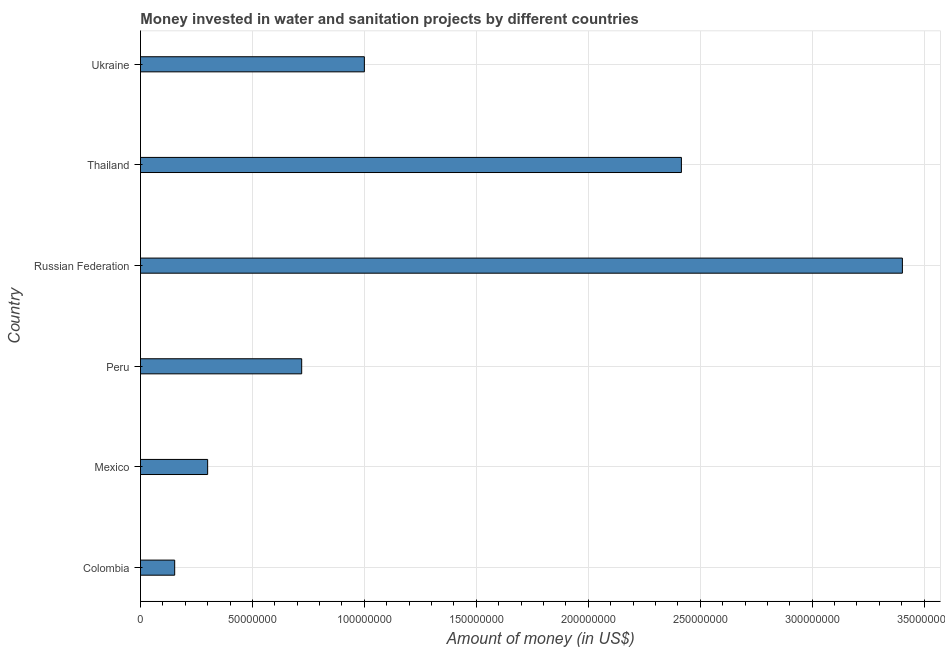Does the graph contain any zero values?
Your answer should be very brief. No. What is the title of the graph?
Your answer should be compact. Money invested in water and sanitation projects by different countries. What is the label or title of the X-axis?
Your answer should be compact. Amount of money (in US$). What is the label or title of the Y-axis?
Your answer should be compact. Country. What is the investment in Mexico?
Provide a short and direct response. 3.00e+07. Across all countries, what is the maximum investment?
Offer a very short reply. 3.40e+08. Across all countries, what is the minimum investment?
Your answer should be compact. 1.53e+07. In which country was the investment maximum?
Offer a terse response. Russian Federation. In which country was the investment minimum?
Keep it short and to the point. Colombia. What is the sum of the investment?
Ensure brevity in your answer.  7.99e+08. What is the difference between the investment in Colombia and Russian Federation?
Keep it short and to the point. -3.25e+08. What is the average investment per country?
Ensure brevity in your answer.  1.33e+08. What is the median investment?
Provide a succinct answer. 8.60e+07. In how many countries, is the investment greater than 80000000 US$?
Give a very brief answer. 3. What is the ratio of the investment in Peru to that in Ukraine?
Your response must be concise. 0.72. What is the difference between the highest and the second highest investment?
Give a very brief answer. 9.87e+07. Is the sum of the investment in Thailand and Ukraine greater than the maximum investment across all countries?
Keep it short and to the point. Yes. What is the difference between the highest and the lowest investment?
Provide a short and direct response. 3.25e+08. In how many countries, is the investment greater than the average investment taken over all countries?
Make the answer very short. 2. How many countries are there in the graph?
Your answer should be very brief. 6. Are the values on the major ticks of X-axis written in scientific E-notation?
Make the answer very short. No. What is the Amount of money (in US$) in Colombia?
Offer a very short reply. 1.53e+07. What is the Amount of money (in US$) of Mexico?
Offer a very short reply. 3.00e+07. What is the Amount of money (in US$) in Peru?
Provide a succinct answer. 7.20e+07. What is the Amount of money (in US$) of Russian Federation?
Offer a terse response. 3.40e+08. What is the Amount of money (in US$) in Thailand?
Ensure brevity in your answer.  2.42e+08. What is the difference between the Amount of money (in US$) in Colombia and Mexico?
Ensure brevity in your answer.  -1.47e+07. What is the difference between the Amount of money (in US$) in Colombia and Peru?
Keep it short and to the point. -5.67e+07. What is the difference between the Amount of money (in US$) in Colombia and Russian Federation?
Keep it short and to the point. -3.25e+08. What is the difference between the Amount of money (in US$) in Colombia and Thailand?
Offer a very short reply. -2.26e+08. What is the difference between the Amount of money (in US$) in Colombia and Ukraine?
Provide a short and direct response. -8.47e+07. What is the difference between the Amount of money (in US$) in Mexico and Peru?
Ensure brevity in your answer.  -4.20e+07. What is the difference between the Amount of money (in US$) in Mexico and Russian Federation?
Keep it short and to the point. -3.10e+08. What is the difference between the Amount of money (in US$) in Mexico and Thailand?
Your answer should be compact. -2.12e+08. What is the difference between the Amount of money (in US$) in Mexico and Ukraine?
Offer a terse response. -7.00e+07. What is the difference between the Amount of money (in US$) in Peru and Russian Federation?
Ensure brevity in your answer.  -2.68e+08. What is the difference between the Amount of money (in US$) in Peru and Thailand?
Provide a succinct answer. -1.70e+08. What is the difference between the Amount of money (in US$) in Peru and Ukraine?
Your answer should be compact. -2.80e+07. What is the difference between the Amount of money (in US$) in Russian Federation and Thailand?
Ensure brevity in your answer.  9.87e+07. What is the difference between the Amount of money (in US$) in Russian Federation and Ukraine?
Ensure brevity in your answer.  2.40e+08. What is the difference between the Amount of money (in US$) in Thailand and Ukraine?
Offer a very short reply. 1.42e+08. What is the ratio of the Amount of money (in US$) in Colombia to that in Mexico?
Ensure brevity in your answer.  0.51. What is the ratio of the Amount of money (in US$) in Colombia to that in Peru?
Your response must be concise. 0.21. What is the ratio of the Amount of money (in US$) in Colombia to that in Russian Federation?
Offer a very short reply. 0.04. What is the ratio of the Amount of money (in US$) in Colombia to that in Thailand?
Offer a very short reply. 0.06. What is the ratio of the Amount of money (in US$) in Colombia to that in Ukraine?
Provide a succinct answer. 0.15. What is the ratio of the Amount of money (in US$) in Mexico to that in Peru?
Keep it short and to the point. 0.42. What is the ratio of the Amount of money (in US$) in Mexico to that in Russian Federation?
Provide a succinct answer. 0.09. What is the ratio of the Amount of money (in US$) in Mexico to that in Thailand?
Keep it short and to the point. 0.12. What is the ratio of the Amount of money (in US$) in Peru to that in Russian Federation?
Make the answer very short. 0.21. What is the ratio of the Amount of money (in US$) in Peru to that in Thailand?
Offer a very short reply. 0.3. What is the ratio of the Amount of money (in US$) in Peru to that in Ukraine?
Your response must be concise. 0.72. What is the ratio of the Amount of money (in US$) in Russian Federation to that in Thailand?
Make the answer very short. 1.41. What is the ratio of the Amount of money (in US$) in Russian Federation to that in Ukraine?
Your answer should be very brief. 3.4. What is the ratio of the Amount of money (in US$) in Thailand to that in Ukraine?
Your answer should be compact. 2.42. 